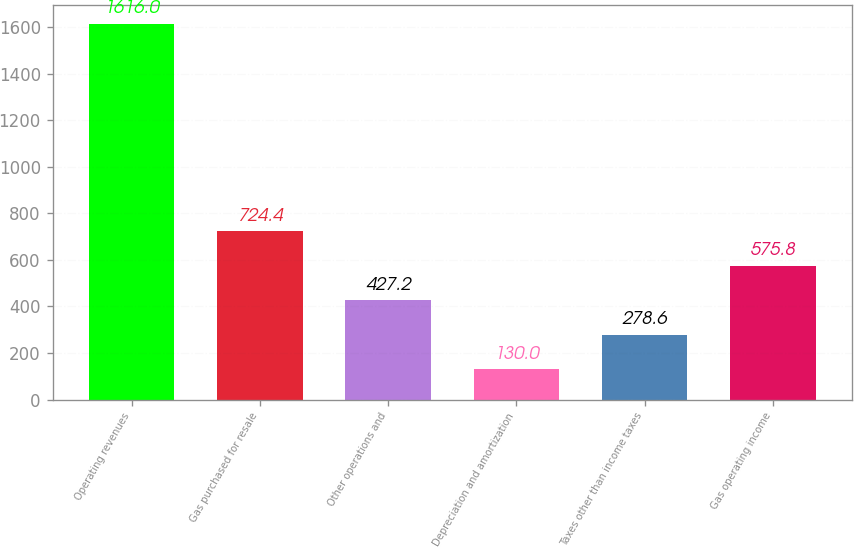Convert chart. <chart><loc_0><loc_0><loc_500><loc_500><bar_chart><fcel>Operating revenues<fcel>Gas purchased for resale<fcel>Other operations and<fcel>Depreciation and amortization<fcel>Taxes other than income taxes<fcel>Gas operating income<nl><fcel>1616<fcel>724.4<fcel>427.2<fcel>130<fcel>278.6<fcel>575.8<nl></chart> 